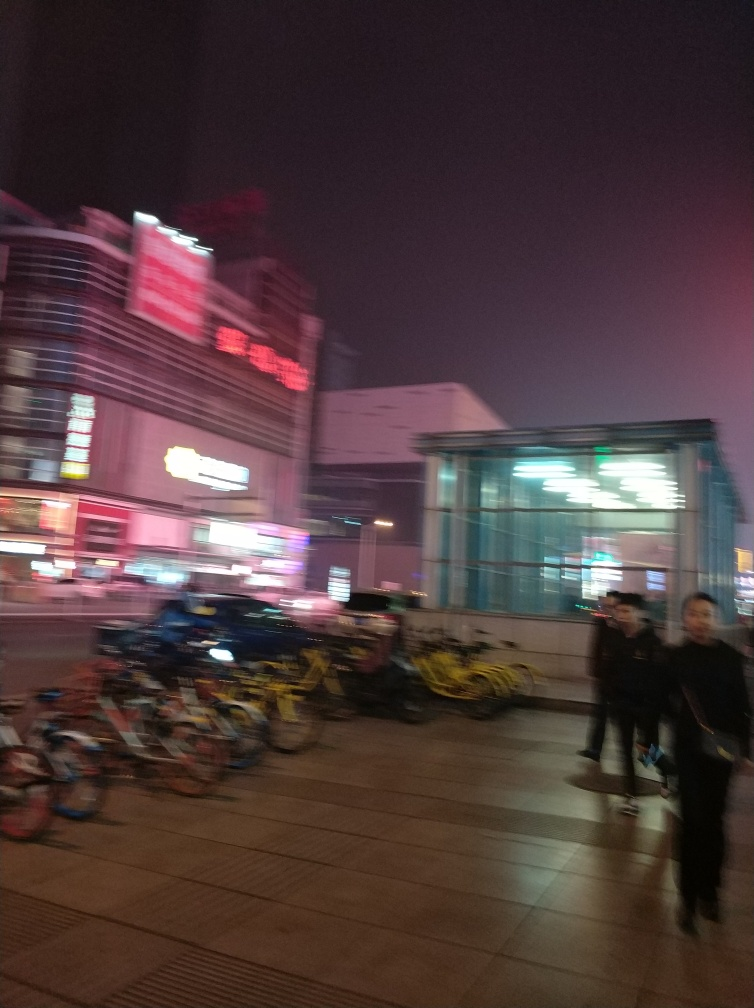What can you infer about the weather conditions in the image? There is no clear evidence of rain or snow, but the overall darkness and artificial light glare may indicate overcast night conditions or early evening mist. 